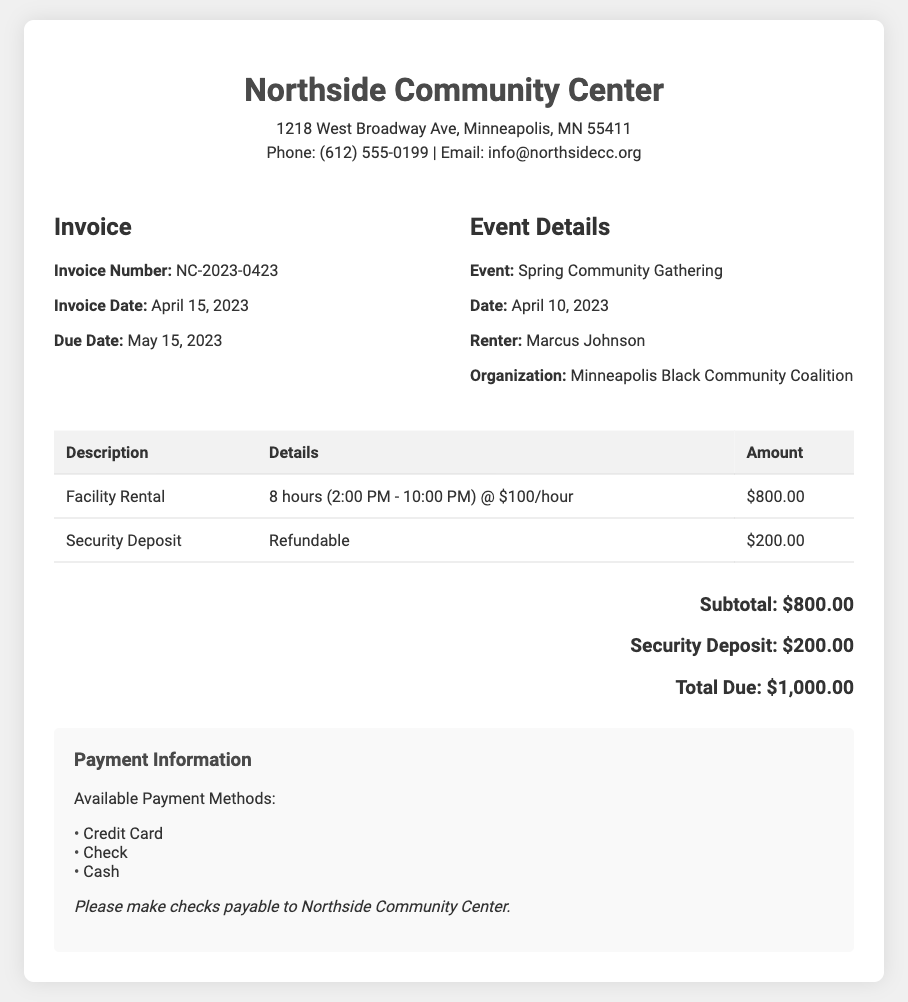What is the invoice number? The invoice number is specified in the document as NC-2023-0423.
Answer: NC-2023-0423 What is the date of the event? The event date is listed as April 10, 2023.
Answer: April 10, 2023 How many hours was the facility rented? The document states the facility was rented for 8 hours.
Answer: 8 hours What is the total due? The total amount due includes the facility rental and the security deposit, totaling $1,000.00.
Answer: $1,000.00 Who is the renter? The renter is identified in the document as Marcus Johnson.
Answer: Marcus Johnson What is the amount for the security deposit? The invoice specifies the security deposit amount as $200.00.
Answer: $200.00 What time did the event start? The event start time is indicated as 2:00 PM.
Answer: 2:00 PM What organization is associated with the event? The organization mentioned in the document is the Minneapolis Black Community Coalition.
Answer: Minneapolis Black Community Coalition What payment methods are accepted? The payment methods listed include Credit Card, Check, and Cash.
Answer: Credit Card, Check, Cash 